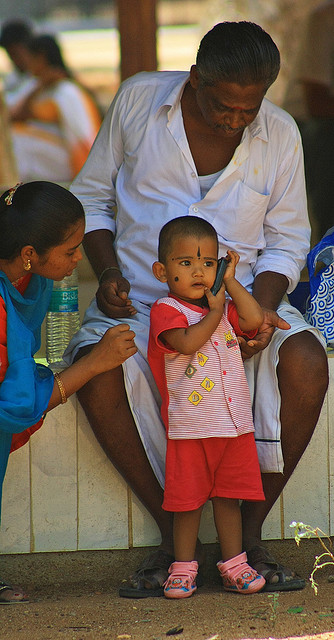What type of phone is being used?
A. pay
B. landline
C. rotary
D. cellular The question appears to be unrelated to the content of the image, which depicts a person sitting and a child standing next to them. There is no phone visible in the image, so it's not possible to answer whether it's a pay, landline, rotary, or cellular phone. However, if you have any questions about the scene, such as the interaction between the individuals or their environment, I'd be glad to provide more information. 